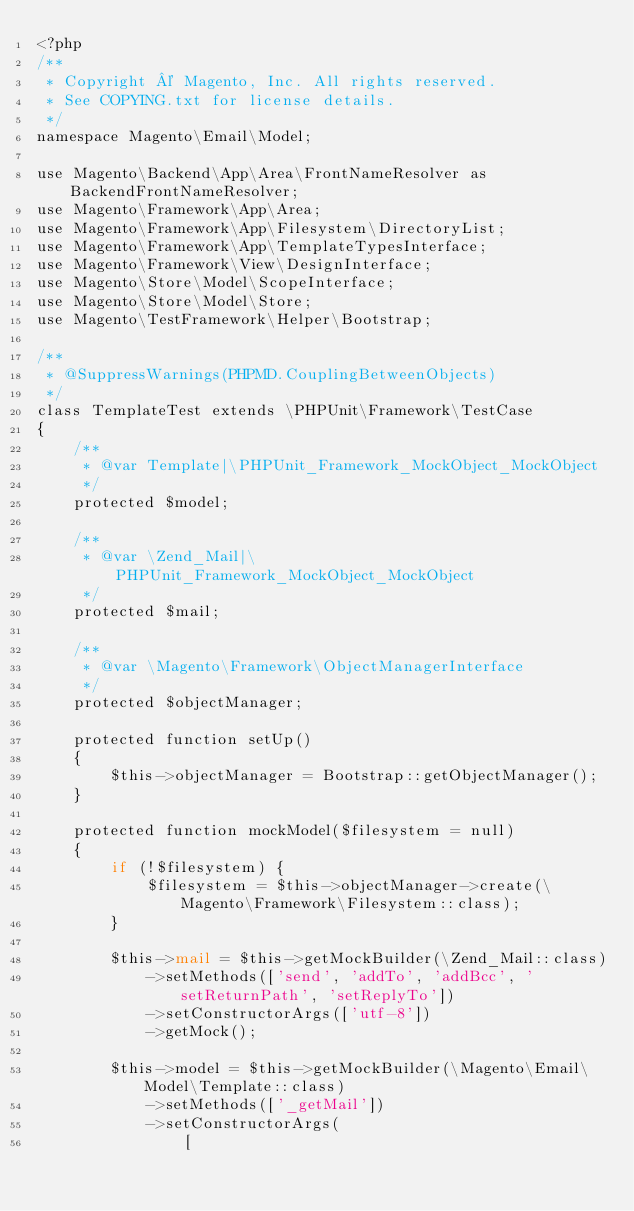<code> <loc_0><loc_0><loc_500><loc_500><_PHP_><?php
/**
 * Copyright © Magento, Inc. All rights reserved.
 * See COPYING.txt for license details.
 */
namespace Magento\Email\Model;

use Magento\Backend\App\Area\FrontNameResolver as BackendFrontNameResolver;
use Magento\Framework\App\Area;
use Magento\Framework\App\Filesystem\DirectoryList;
use Magento\Framework\App\TemplateTypesInterface;
use Magento\Framework\View\DesignInterface;
use Magento\Store\Model\ScopeInterface;
use Magento\Store\Model\Store;
use Magento\TestFramework\Helper\Bootstrap;

/**
 * @SuppressWarnings(PHPMD.CouplingBetweenObjects)
 */
class TemplateTest extends \PHPUnit\Framework\TestCase
{
    /**
     * @var Template|\PHPUnit_Framework_MockObject_MockObject
     */
    protected $model;

    /**
     * @var \Zend_Mail|\PHPUnit_Framework_MockObject_MockObject
     */
    protected $mail;

    /**
     * @var \Magento\Framework\ObjectManagerInterface
     */
    protected $objectManager;

    protected function setUp()
    {
        $this->objectManager = Bootstrap::getObjectManager();
    }

    protected function mockModel($filesystem = null)
    {
        if (!$filesystem) {
            $filesystem = $this->objectManager->create(\Magento\Framework\Filesystem::class);
        }

        $this->mail = $this->getMockBuilder(\Zend_Mail::class)
            ->setMethods(['send', 'addTo', 'addBcc', 'setReturnPath', 'setReplyTo'])
            ->setConstructorArgs(['utf-8'])
            ->getMock();

        $this->model = $this->getMockBuilder(\Magento\Email\Model\Template::class)
            ->setMethods(['_getMail'])
            ->setConstructorArgs(
                [</code> 